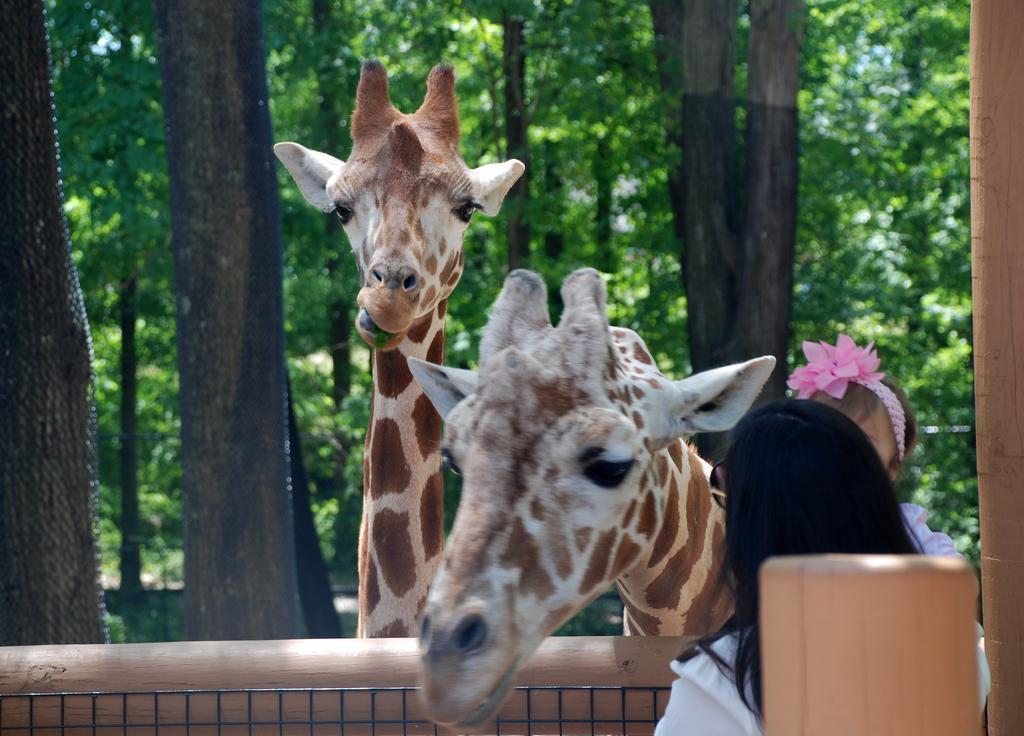In one or two sentences, can you explain what this image depicts? On the right side of the image we can see one person is standing and she is holding a kid. And we can see one pole and one wooden object. In the center of the image, we can see two giraffes. At the bottom of the image, there is a mesh and one wooden object. In the background, we can see trees. 